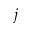Convert formula to latex. <formula><loc_0><loc_0><loc_500><loc_500>j</formula> 